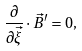<formula> <loc_0><loc_0><loc_500><loc_500>\frac { \partial } { \partial { \vec { \xi } } } \cdot \vec { B } ^ { \prime } = 0 ,</formula> 